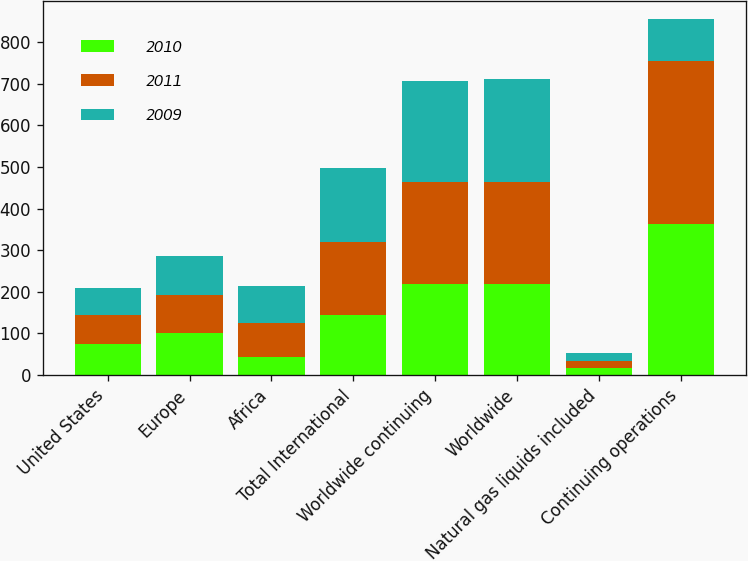<chart> <loc_0><loc_0><loc_500><loc_500><stacked_bar_chart><ecel><fcel>United States<fcel>Europe<fcel>Africa<fcel>Total International<fcel>Worldwide continuing<fcel>Worldwide<fcel>Natural gas liquids included<fcel>Continuing operations<nl><fcel>2010<fcel>75<fcel>101<fcel>43<fcel>144<fcel>219<fcel>219<fcel>17<fcel>363<nl><fcel>2011<fcel>70<fcel>92<fcel>83<fcel>175<fcel>245<fcel>245<fcel>16<fcel>391<nl><fcel>2009<fcel>64<fcel>92<fcel>87<fcel>179<fcel>243<fcel>248<fcel>19<fcel>101<nl></chart> 